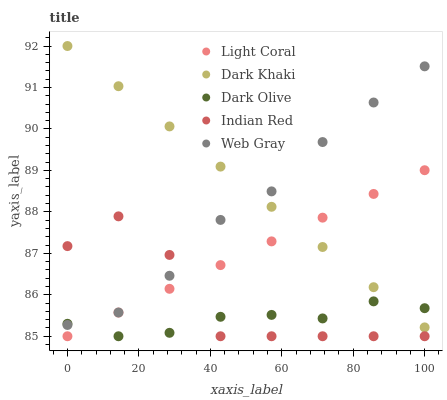Does Dark Olive have the minimum area under the curve?
Answer yes or no. Yes. Does Dark Khaki have the maximum area under the curve?
Answer yes or no. Yes. Does Dark Khaki have the minimum area under the curve?
Answer yes or no. No. Does Dark Olive have the maximum area under the curve?
Answer yes or no. No. Is Dark Khaki the smoothest?
Answer yes or no. Yes. Is Indian Red the roughest?
Answer yes or no. Yes. Is Dark Olive the smoothest?
Answer yes or no. No. Is Dark Olive the roughest?
Answer yes or no. No. Does Light Coral have the lowest value?
Answer yes or no. Yes. Does Dark Khaki have the lowest value?
Answer yes or no. No. Does Dark Khaki have the highest value?
Answer yes or no. Yes. Does Dark Olive have the highest value?
Answer yes or no. No. Is Light Coral less than Web Gray?
Answer yes or no. Yes. Is Dark Khaki greater than Indian Red?
Answer yes or no. Yes. Does Web Gray intersect Dark Khaki?
Answer yes or no. Yes. Is Web Gray less than Dark Khaki?
Answer yes or no. No. Is Web Gray greater than Dark Khaki?
Answer yes or no. No. Does Light Coral intersect Web Gray?
Answer yes or no. No. 